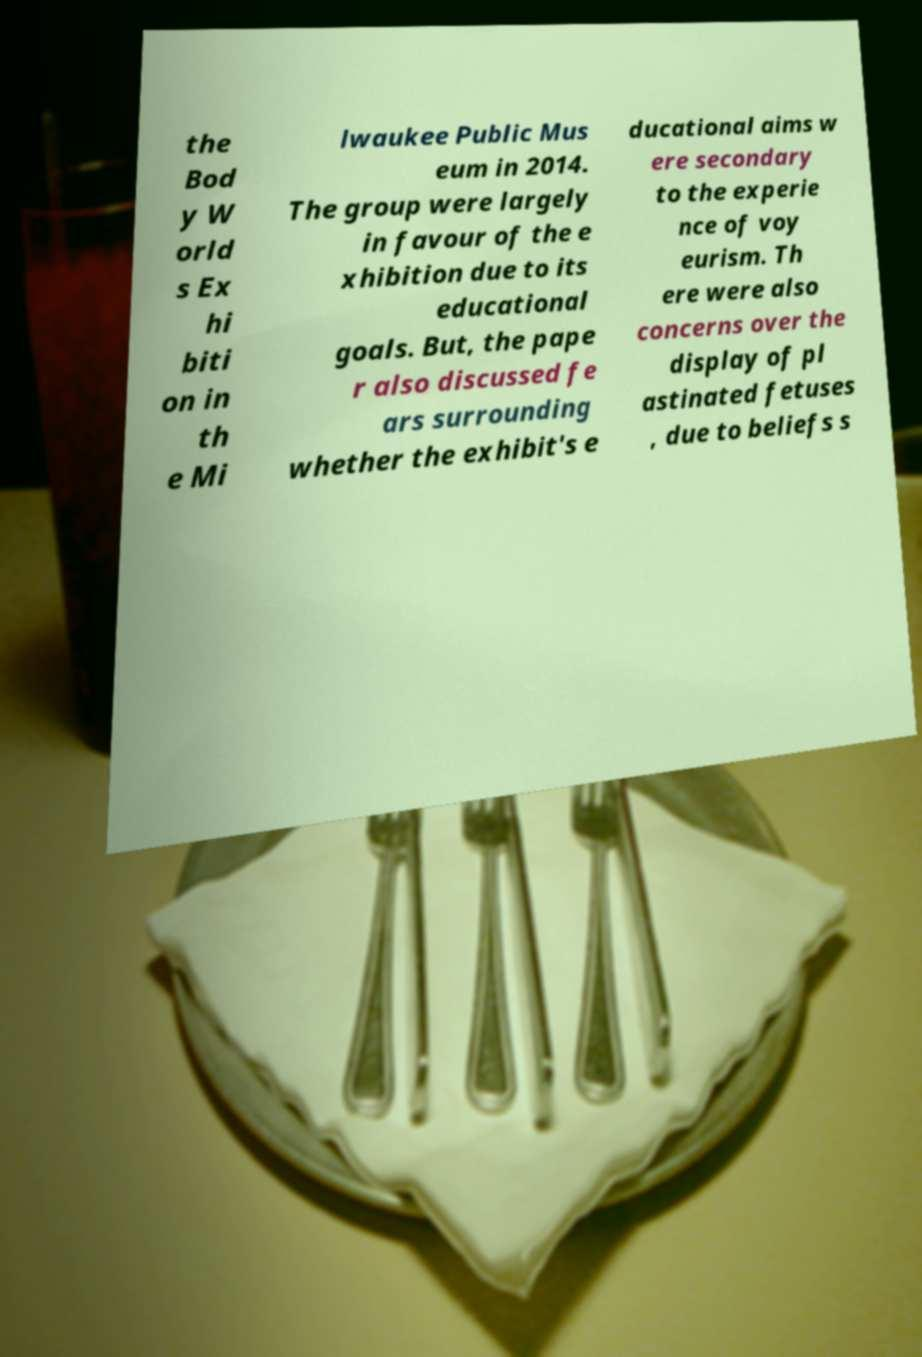Please read and relay the text visible in this image. What does it say? the Bod y W orld s Ex hi biti on in th e Mi lwaukee Public Mus eum in 2014. The group were largely in favour of the e xhibition due to its educational goals. But, the pape r also discussed fe ars surrounding whether the exhibit's e ducational aims w ere secondary to the experie nce of voy eurism. Th ere were also concerns over the display of pl astinated fetuses , due to beliefs s 